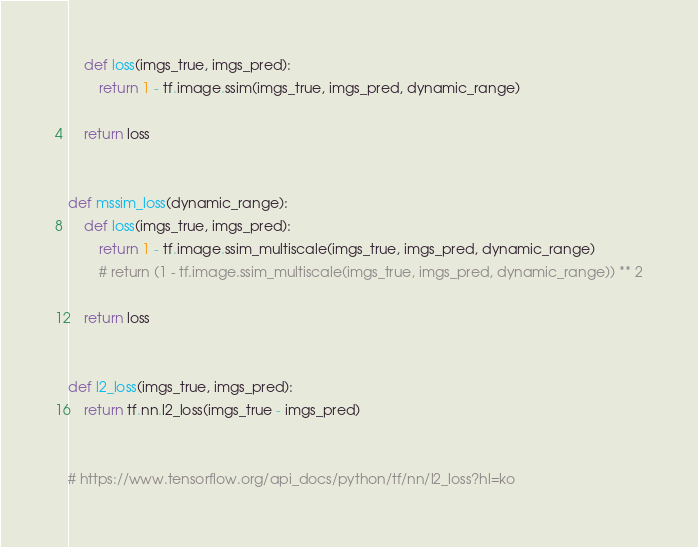Convert code to text. <code><loc_0><loc_0><loc_500><loc_500><_Python_>    def loss(imgs_true, imgs_pred):
        return 1 - tf.image.ssim(imgs_true, imgs_pred, dynamic_range)

    return loss


def mssim_loss(dynamic_range):
    def loss(imgs_true, imgs_pred):
        return 1 - tf.image.ssim_multiscale(imgs_true, imgs_pred, dynamic_range)
        # return (1 - tf.image.ssim_multiscale(imgs_true, imgs_pred, dynamic_range)) ** 2

    return loss


def l2_loss(imgs_true, imgs_pred):
    return tf.nn.l2_loss(imgs_true - imgs_pred)


# https://www.tensorflow.org/api_docs/python/tf/nn/l2_loss?hl=ko
</code> 